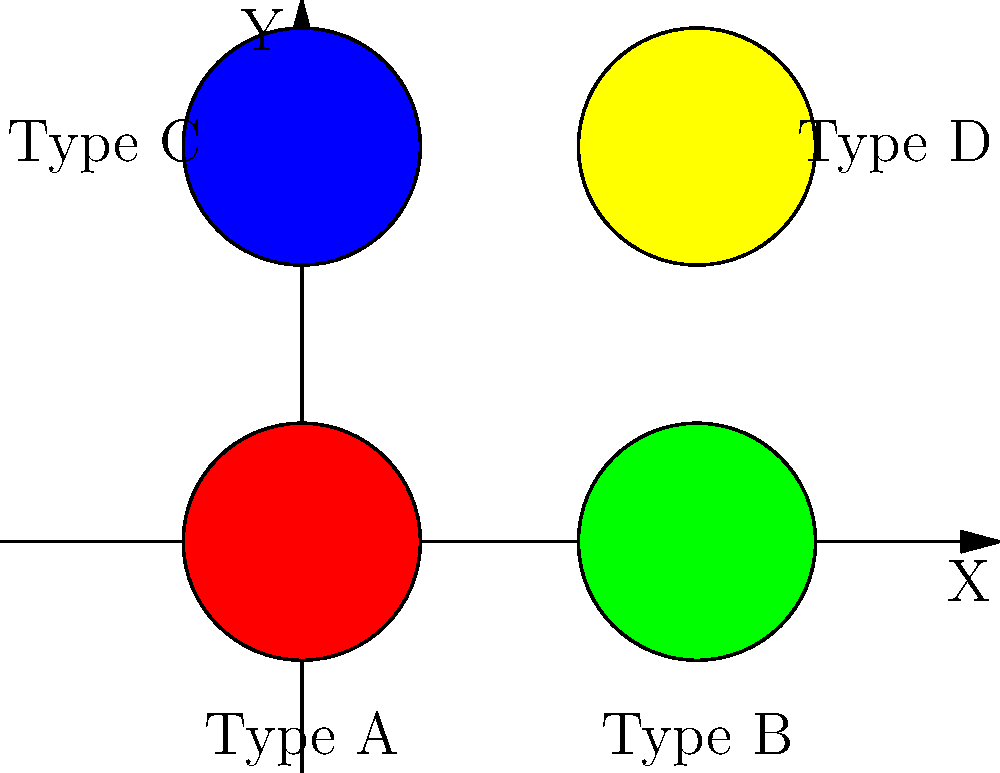After learning about electric cars in your school presentation, you're now working on a machine learning project to classify charging station types from satellite images. Given the overhead view of four different charging station types (A, B, C, and D) represented by colored circles, which machine learning algorithm would be most suitable for this classification task, and why? To determine the most suitable machine learning algorithm for classifying charging station types from satellite images, let's consider the problem and the data:

1. Problem type: This is a classification task, as we need to categorize charging stations into four distinct types (A, B, C, and D).

2. Data characteristics:
   - The input data consists of images (satellite views).
   - The images contain visual features like color and shape.
   - Spatial relationships between features may be important.

3. Considering these factors, a Convolutional Neural Network (CNN) would be the most suitable algorithm:

   a) CNNs are designed specifically for image classification tasks.
   b) They can automatically learn and extract relevant features from images.
   c) CNNs use convolutional layers to detect patterns and spatial relationships.
   d) They can handle complex, high-dimensional data like satellite images.
   e) CNNs have shown excellent performance in similar image classification tasks.

4. Other algorithms like Support Vector Machines (SVM) or Random Forests could also be used, but they may require more manual feature engineering and might not capture spatial relationships as effectively as CNNs.

5. For this specific task, a CNN architecture like ResNet or VGG, pre-trained on a large dataset and fine-tuned on charging station images, would likely yield the best results.
Answer: Convolutional Neural Network (CNN) 